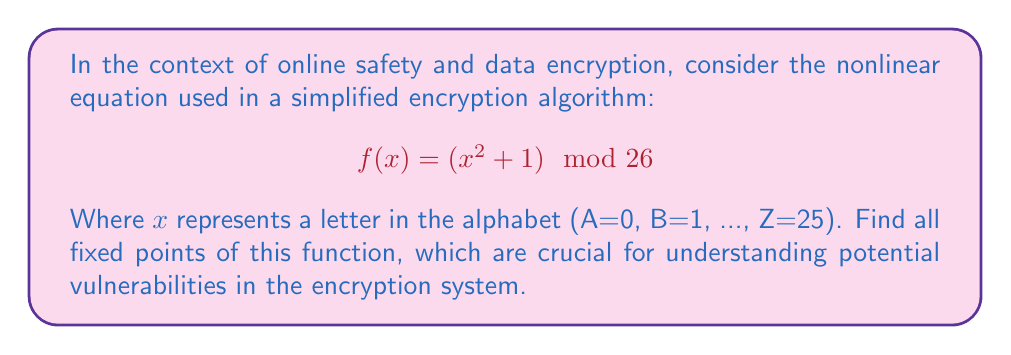Show me your answer to this math problem. To find the fixed points, we need to solve the equation $f(x) = x$:

1) Set up the equation:
   $$(x^2 + 1) \mod 26 = x$$

2) This is equivalent to solving:
   $$x^2 + 1 = x + 26k$$
   where $k$ is some integer.

3) Rearrange the equation:
   $$x^2 - x + (1 - 26k) = 0$$

4) This is a quadratic equation. For it to have integer solutions (remember, x represents letters), the discriminant must be a perfect square. The discriminant is:
   $$b^2 - 4ac = 1 - 4(1 - 26k) = 4(26k - 1) + 1 = 104k - 3$$

5) We need to find $k$ such that $104k - 3$ is a perfect square. The smallest positive value that works is $k = 1$:
   $$104(1) - 3 = 101 = 10^2 + 1$$

6) With $k = 1$, our equation becomes:
   $$x^2 - x - 25 = 0$$

7) Solve this using the quadratic formula:
   $$x = \frac{1 \pm \sqrt{1 + 4(25)}}{2} = \frac{1 \pm 10}{2}$$

8) This gives us two solutions: $x = \frac{11}{2}$ and $x = -\frac{9}{2}$

9) Since we're working modulo 26, and we need integer values, these solutions correspond to:
   $x \equiv 5.5 \mod 26$ and $x \equiv -4.5 \mod 26$
   which simplify to:
   $x \equiv 6 \mod 26$ and $x \equiv 21 \mod 26$

10) Therefore, the fixed points are 6 and 21, corresponding to letters G and V in the alphabet.
Answer: G (6) and V (21) 